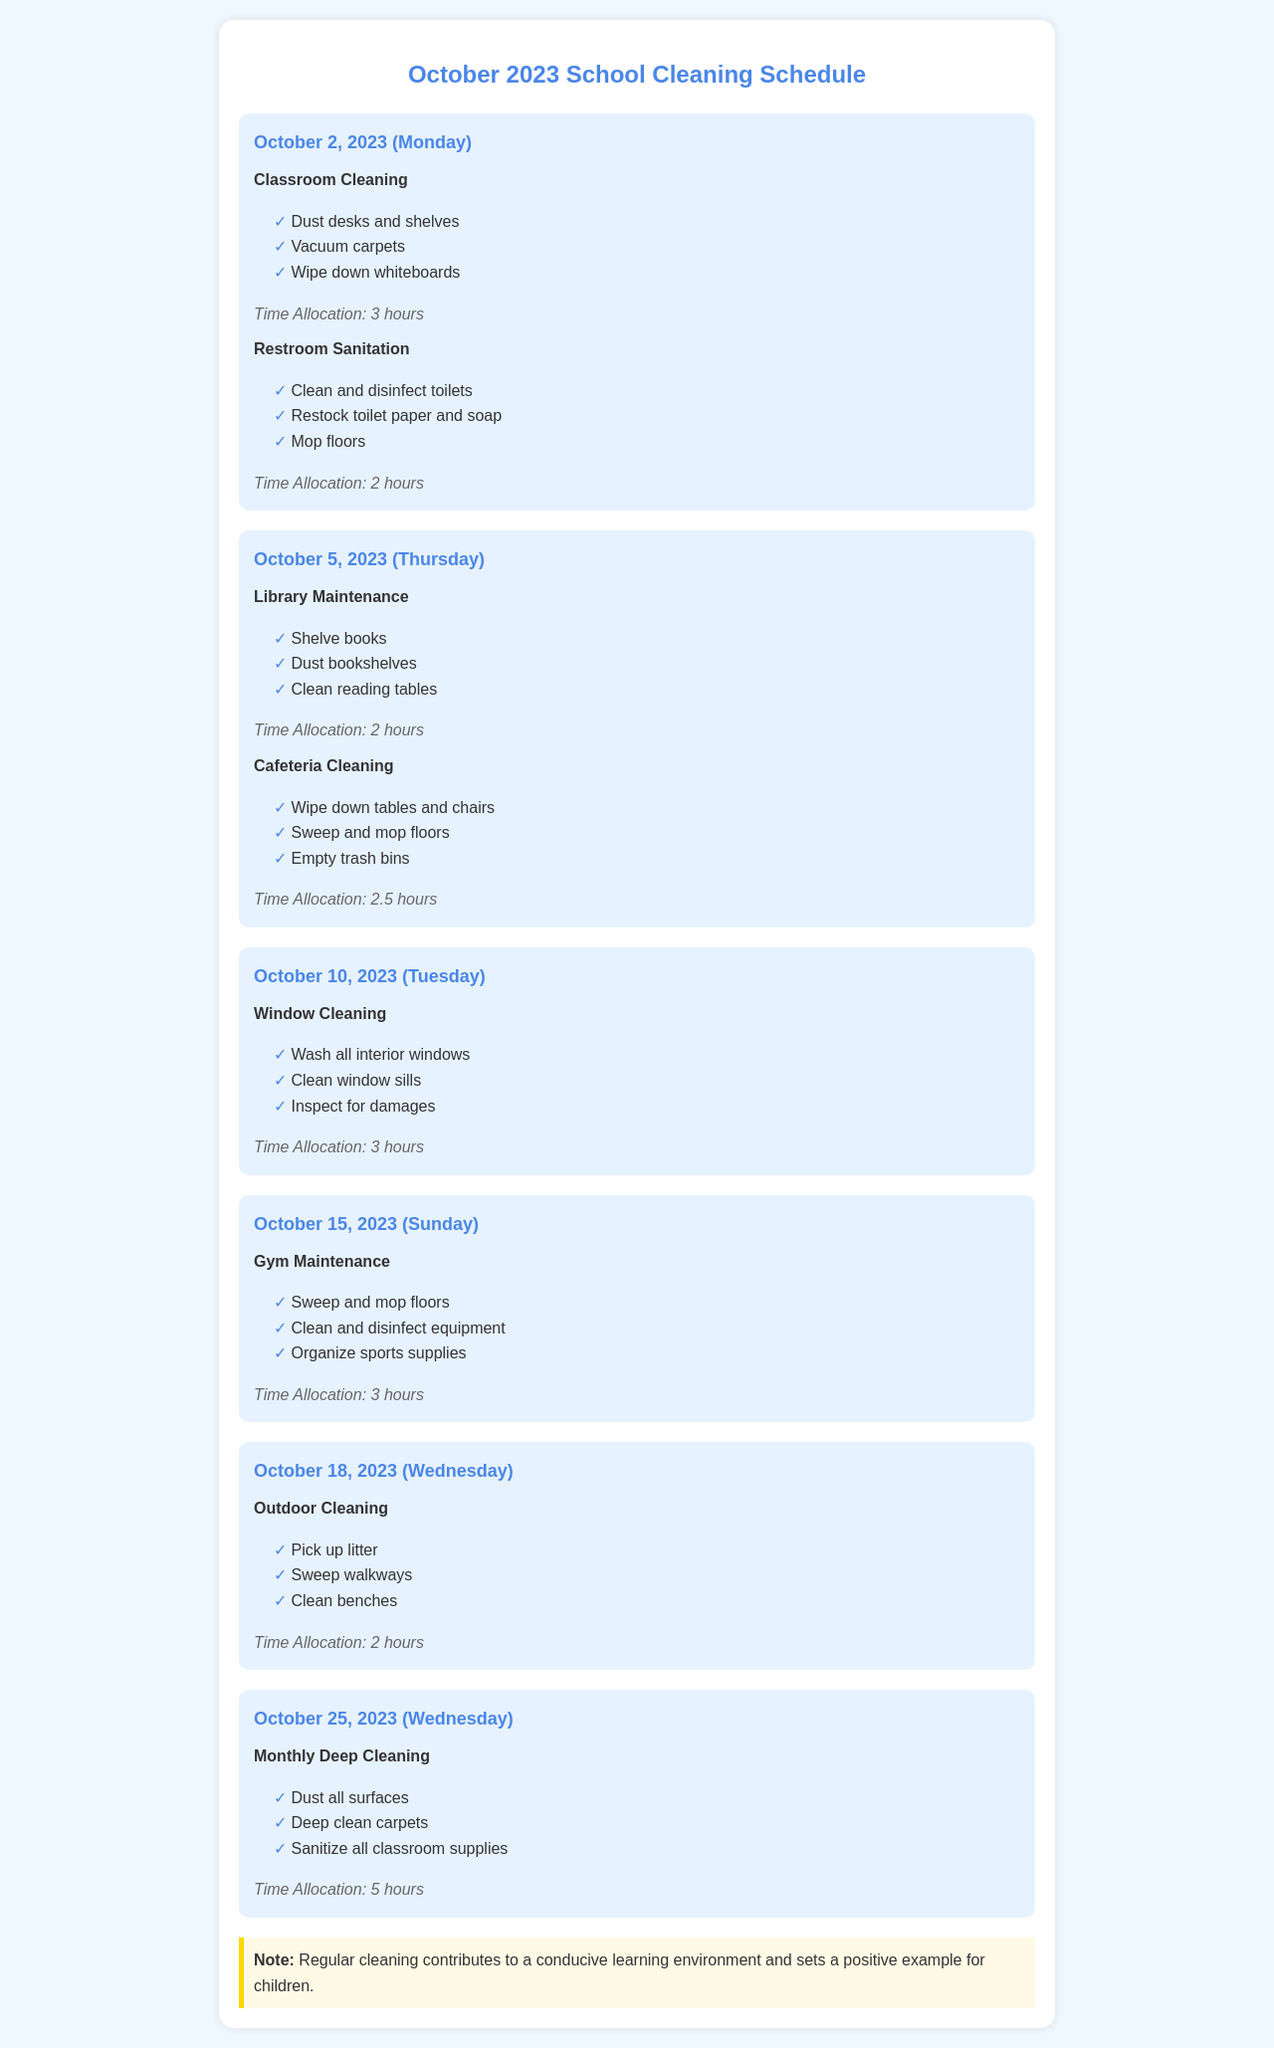What is the date for the Monthly Deep Cleaning? The date for the Monthly Deep Cleaning is listed in the schedule, which is October 25, 2023.
Answer: October 25, 2023 How long is the time allocated for Gym Maintenance? The time allocated for Gym Maintenance is specified under the relevant task in the document, which is 3 hours.
Answer: 3 hours Which two tasks are scheduled for October 5, 2023? The tasks scheduled for October 5, 2023, are listed in the document and include Library Maintenance and Cafeteria Cleaning.
Answer: Library Maintenance and Cafeteria Cleaning What is the primary task to be performed on October 10, 2023? The primary task for October 10, 2023, is indicated in the document, which focuses on Window Cleaning.
Answer: Window Cleaning How many hours are allocated for Monthly Deep Cleaning? The hours allocated for Monthly Deep Cleaning can be found in the schedule and it states that 5 hours are required.
Answer: 5 hours What is the note at the end of the schedule emphasizing? The note emphasizes the importance of regular cleaning for a conducive learning environment, reflecting the sentiments expressed in the document.
Answer: A conducive learning environment On which day is the Outdoor Cleaning scheduled? The day for Outdoor Cleaning is specified in the schedule as October 18, 2023.
Answer: October 18, 2023 Which task includes inspecting for damages? The task that includes inspecting for damages is detailed under Window Cleaning in the schedule provided.
Answer: Window Cleaning What is the total time allocated for tasks on October 2, 2023? The total time allocated for tasks on October 2, 2023, can be calculated from the two tasks listed, which total 5 hours.
Answer: 5 hours 